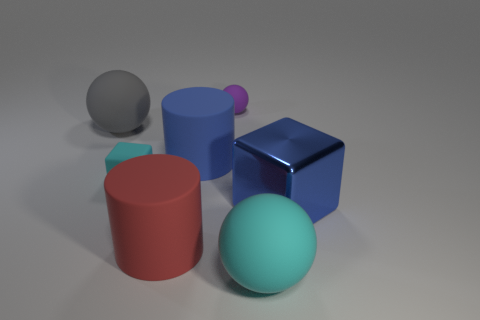What is the size of the matte ball in front of the large cylinder behind the red cylinder?
Offer a terse response. Large. Does the blue thing left of the purple rubber sphere have the same shape as the big blue thing that is in front of the matte block?
Give a very brief answer. No. What color is the rubber thing that is both to the right of the large gray rubber object and to the left of the big red rubber thing?
Keep it short and to the point. Cyan. Is there a big rubber thing that has the same color as the small rubber block?
Provide a succinct answer. Yes. What is the color of the tiny object that is on the right side of the cyan matte cube?
Your response must be concise. Purple. There is a cyan rubber object that is to the right of the small rubber cube; is there a small cyan matte block on the right side of it?
Offer a very short reply. No. Do the metal thing and the tiny rubber thing behind the tiny cyan matte block have the same color?
Offer a terse response. No. Are there any large balls made of the same material as the large blue cylinder?
Ensure brevity in your answer.  Yes. How many large yellow metallic balls are there?
Ensure brevity in your answer.  0. What is the big ball right of the object that is to the left of the cyan block made of?
Your answer should be very brief. Rubber. 